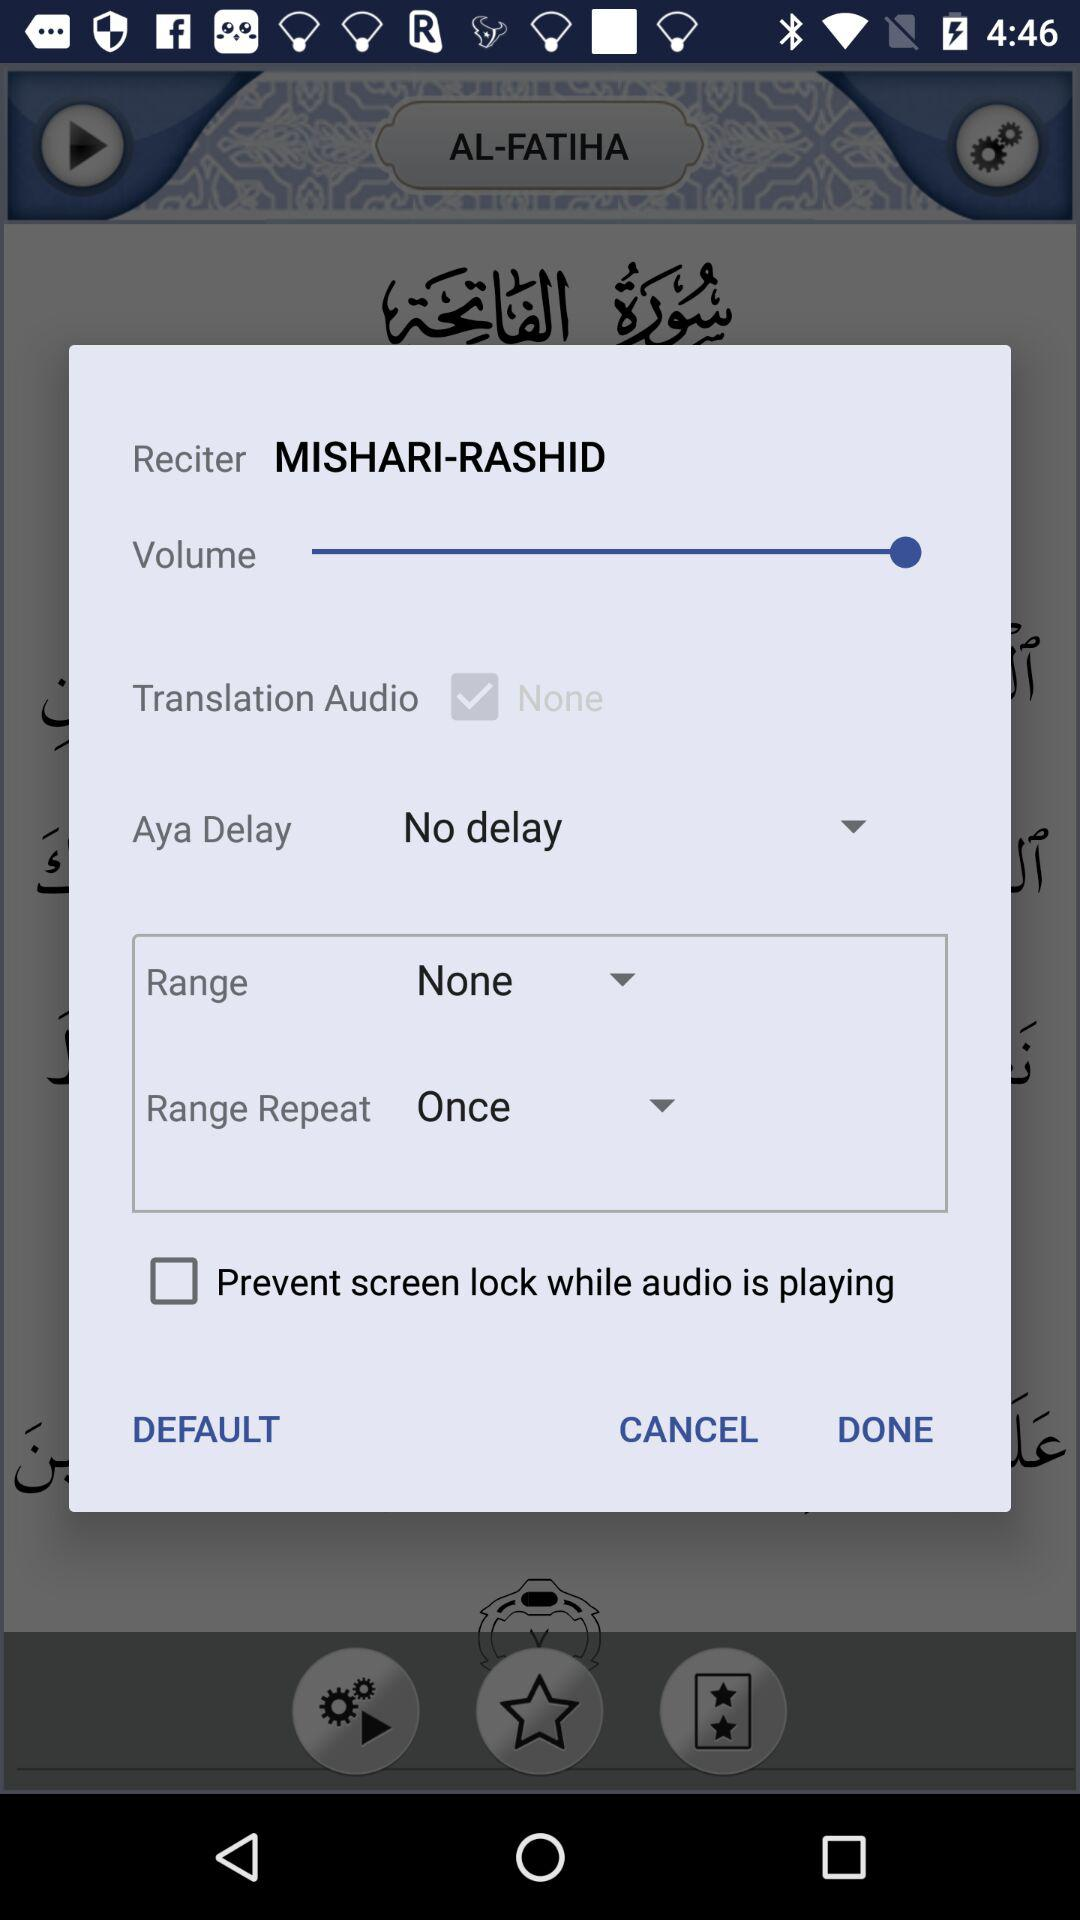What is the reciter name? The reciter name is Mishari Rashid. 